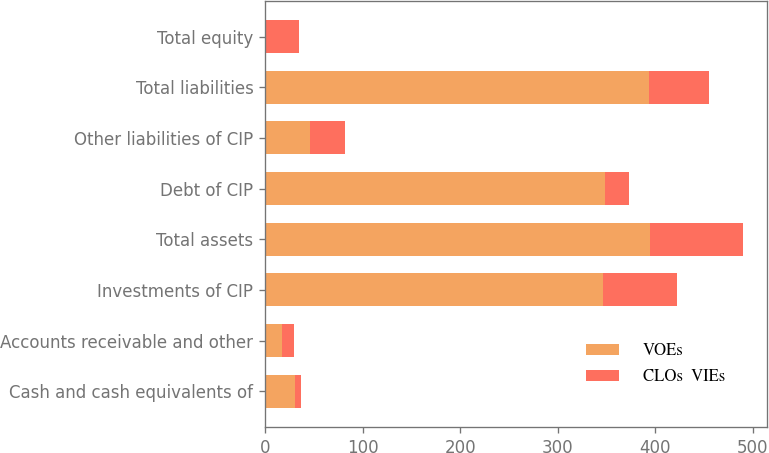Convert chart. <chart><loc_0><loc_0><loc_500><loc_500><stacked_bar_chart><ecel><fcel>Cash and cash equivalents of<fcel>Accounts receivable and other<fcel>Investments of CIP<fcel>Total assets<fcel>Debt of CIP<fcel>Other liabilities of CIP<fcel>Total liabilities<fcel>Total equity<nl><fcel>VOEs<fcel>30.5<fcel>17.6<fcel>346.5<fcel>394.6<fcel>347.9<fcel>45.7<fcel>393.6<fcel>1<nl><fcel>CLOs  VIEs<fcel>6.6<fcel>12.1<fcel>76.1<fcel>94.8<fcel>25<fcel>36<fcel>61<fcel>33.8<nl></chart> 